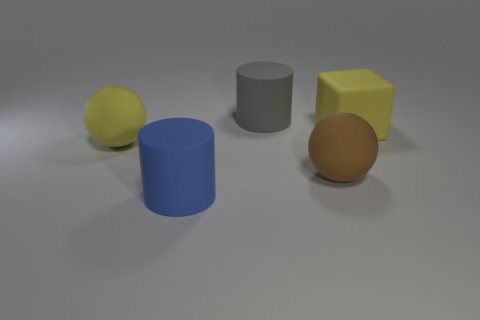Add 2 large gray matte objects. How many objects exist? 7 Subtract all cubes. How many objects are left? 4 Add 2 blue matte objects. How many blue matte objects exist? 3 Subtract 0 blue balls. How many objects are left? 5 Subtract all gray objects. Subtract all big yellow spheres. How many objects are left? 3 Add 2 large yellow matte balls. How many large yellow matte balls are left? 3 